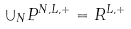<formula> <loc_0><loc_0><loc_500><loc_500>\cup _ { N } P ^ { N , L , + } = R ^ { L , + }</formula> 